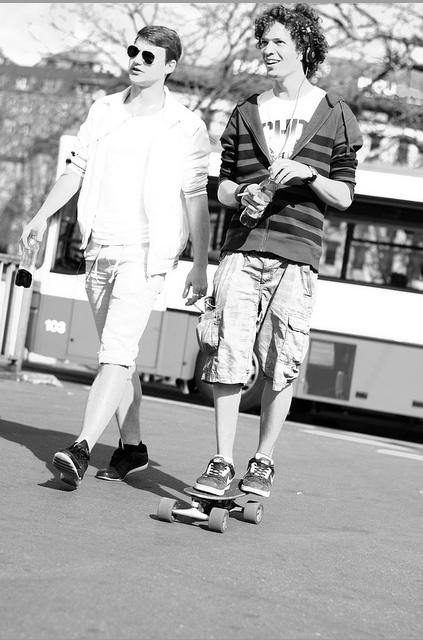What is the person on the left doing? walking 